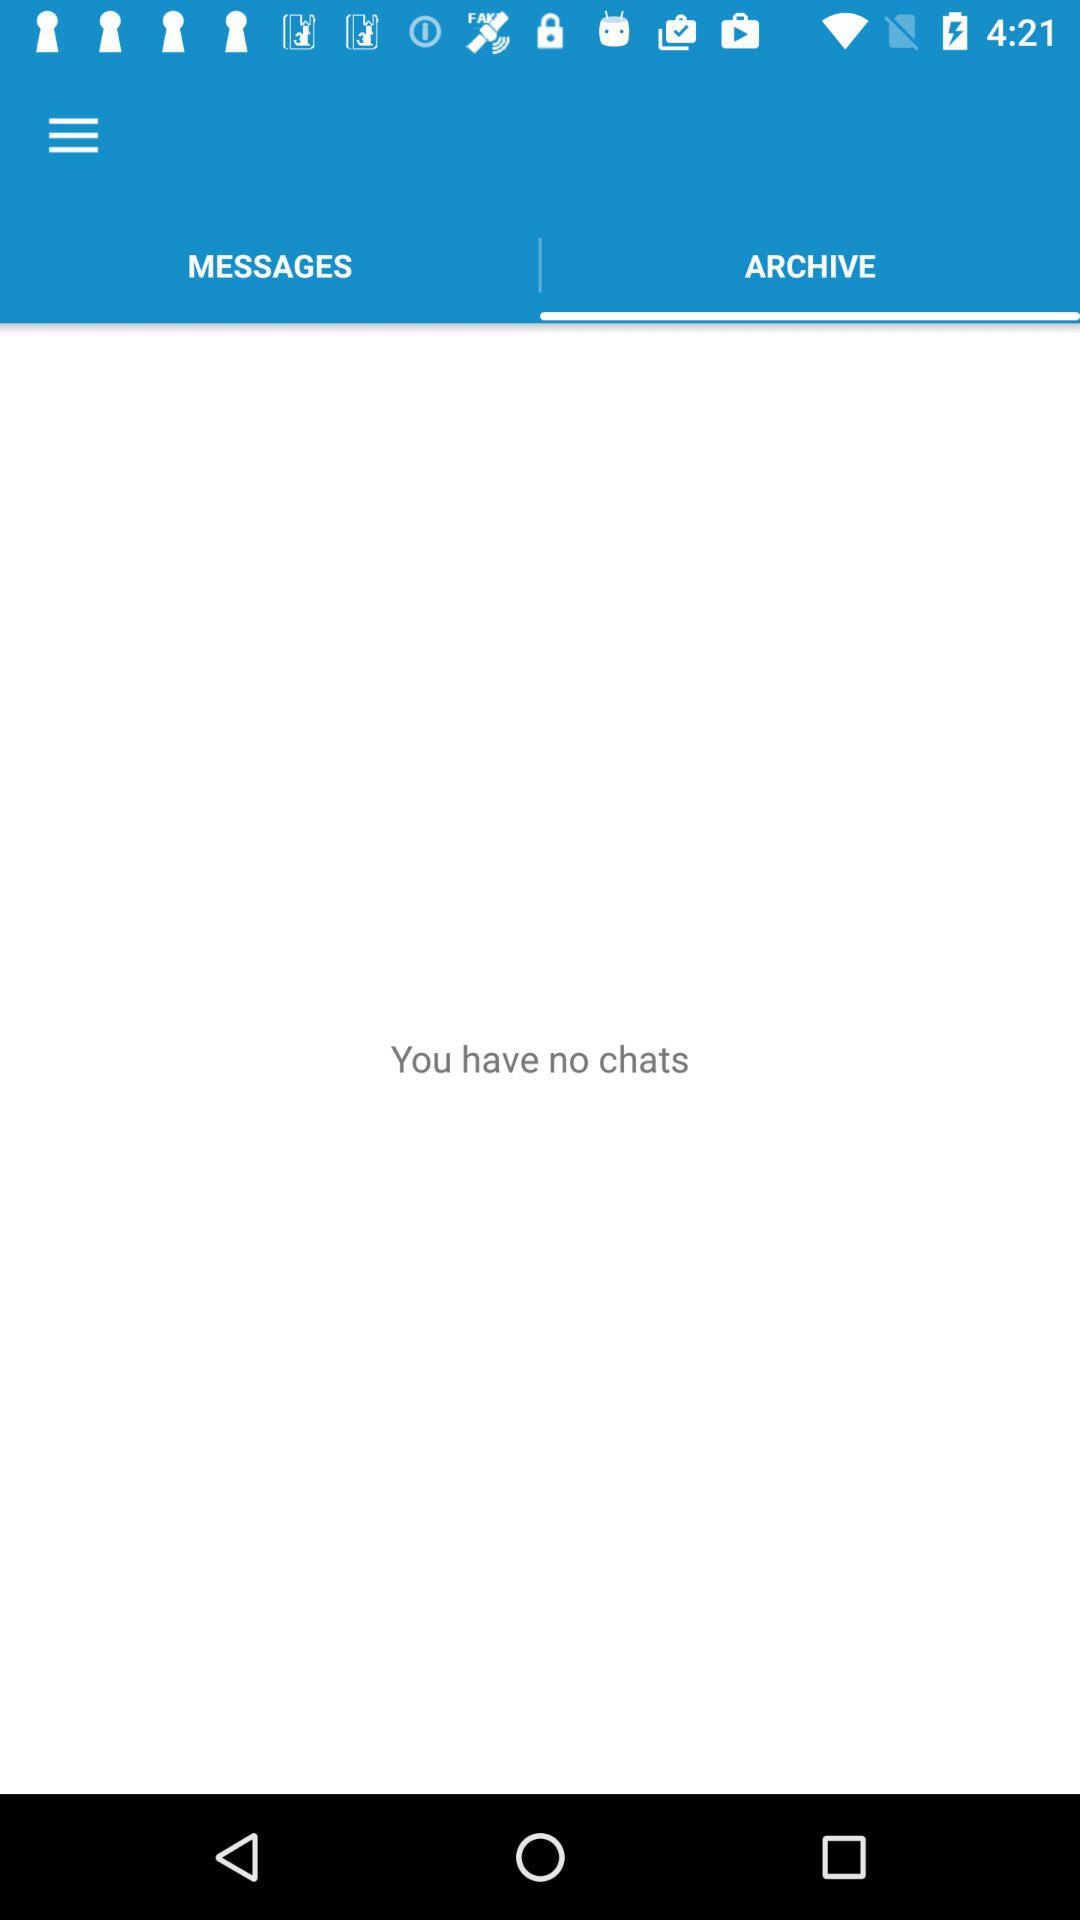Which option is selected? The selected option is "ARCHIVE". 